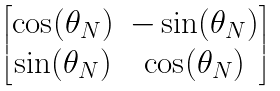Convert formula to latex. <formula><loc_0><loc_0><loc_500><loc_500>\begin{bmatrix} \cos ( \theta _ { N } ) & - \sin ( \theta _ { N } ) \\ \sin ( \theta _ { N } ) & \cos ( \theta _ { N } ) \end{bmatrix}</formula> 